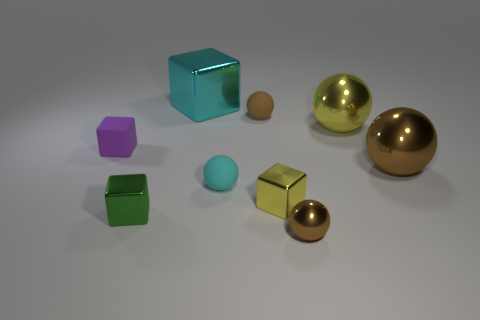Is the color of the big metal sphere on the left side of the large brown object the same as the tiny metallic cube to the right of the cyan ball?
Give a very brief answer. Yes. How many balls are the same color as the large shiny block?
Offer a very short reply. 1. Are there any big yellow metallic objects that have the same shape as the cyan metal thing?
Make the answer very short. No. There is a yellow object in front of the rubber block; is it the same size as the brown shiny sphere right of the tiny brown metal object?
Keep it short and to the point. No. Are there fewer tiny yellow cubes in front of the green shiny object than cyan metallic blocks that are right of the large yellow shiny thing?
Your answer should be very brief. No. There is a big ball that is the same color as the small metallic ball; what is it made of?
Provide a succinct answer. Metal. What color is the metal block left of the big cyan block?
Provide a succinct answer. Green. Do the big metal block and the rubber block have the same color?
Offer a very short reply. No. There is a yellow metal object to the right of the yellow metal cube right of the big metallic cube; what number of tiny yellow metal objects are behind it?
Ensure brevity in your answer.  0. The green shiny object is what size?
Offer a terse response. Small. 